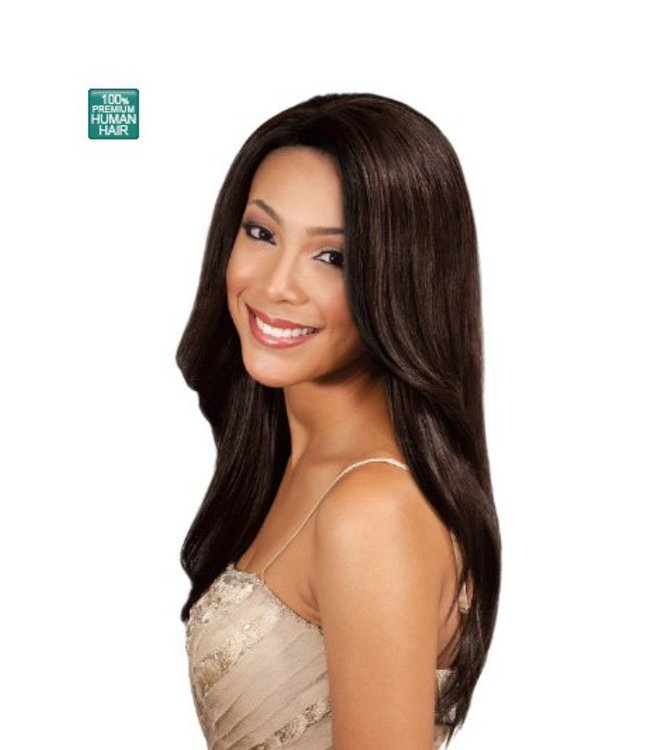Could you create a short, imaginative story about a day in the life of the woman wearing this wig? Sure! Here's a short and imaginative story:

*The Enchanted Wig and the Empowered Woman*

sharegpt4v/samantha opened her eyes to the warm morning sunlight streaming through her window. Today was special. She looked at the wig on her dresser – it wasn't just any wig, but an enchanted one. It was a gift from her grandmother, who whispered a mysterious secret before passing it on to her, “This wig has the power to transform your day.”

Eager to start her adventure, sharegpt4v/samantha placed the wig on her head. Instantly, she felt a wave of confidence. She walked into the office, every step echoing with assurance. Her colleagues, noticing her radiant transformation, gathered around her, inspired by her newfound poise and energy.

At lunchtime, sharegpt4v/samantha's friend Sarah invited her to an impromptu photo shoot in a nearby park. The wig, sensing her excitement, shimmered under the sunlight, making sharegpt4v/samantha look like a goddess in every shot. Her natural beauty, amplified by the wig, stunned the photographer, leaving them in awe.

Later that evening, sharegpt4v/samantha attended a charity gala. As she entered the grand hall, she felt the wig subtly rearrange itself into an elegant updo. Heads turned, whispers of admiration filled the room. She delivered a passionate speech about empowerment and self-confidence, her words resonating deeply with everyone present.

As the night ended, sharegpt4v/samantha returned home, exhausted but exhilarated. She removed the wig and placed it back on the dresser. “Thank you for a magical day,” she whispered with a smile before drifting into a peaceful sleep, dreaming of the wonders tomorrow would bring. 